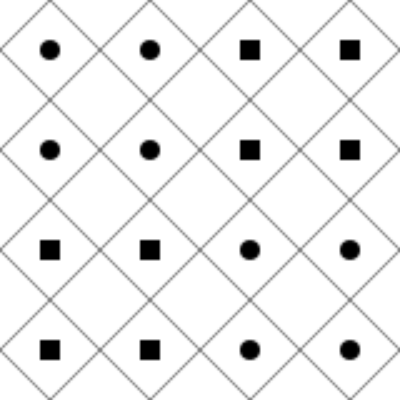In the tessellation above, how many complete diamond shapes are formed by the pattern? Relate this to the concept of identifying algebraic structures in abstract algebra. To solve this problem and relate it to abstract algebraic concepts, let's follow these steps:

1. Identify the basic unit of the tessellation:
   The basic unit is a diamond shape with either a circle or a square in the center.

2. Count the complete diamond shapes:
   - There are 4 quadrants in the image.
   - Each quadrant contains 4 complete diamond shapes.
   - Total number of complete diamond shapes: $4 \times 4 = 16$

3. Relation to algebraic structures:
   a) Pattern recognition in tessellations is analogous to identifying algebraic structures:
      - The diamond shape represents a fundamental "element" in the pattern.
      - The arrangement of diamonds forms a larger structure, similar to how algebraic elements form groups or rings.

   b) Symmetry in the tessellation:
      - The pattern exhibits rotational and reflectional symmetry.
      - This is similar to symmetry groups in abstract algebra, where operations preserve certain properties.

   c) Transformations:
      - The transition from circles to squares in the centers can be seen as a transformation.
      - In abstract algebra, homomorphisms and isomorphisms describe transformations between algebraic structures.

   d) Modularity:
      - The repeating nature of the pattern every 2x2 grid is similar to modular arithmetic in abstract algebra.
      - We can define operations on this pattern that would behave similarly to operations in a finite algebraic structure.

4. Cognitive connection:
   The ability to quickly identify patterns in tessellations correlates with the capacity to recognize and manipulate abstract algebraic structures. Both skills require:
   - Pattern recognition
   - Spatial reasoning
   - Abstract thinking
   - Understanding of symmetry and transformations

By exercising spatial intelligence through tasks like this, students may develop cognitive frameworks that support their understanding of complex algebraic concepts.
Answer: 16 diamonds; pattern recognition in tessellations parallels identifying algebraic structures, utilizing symmetry, transformations, and modularity concepts. 